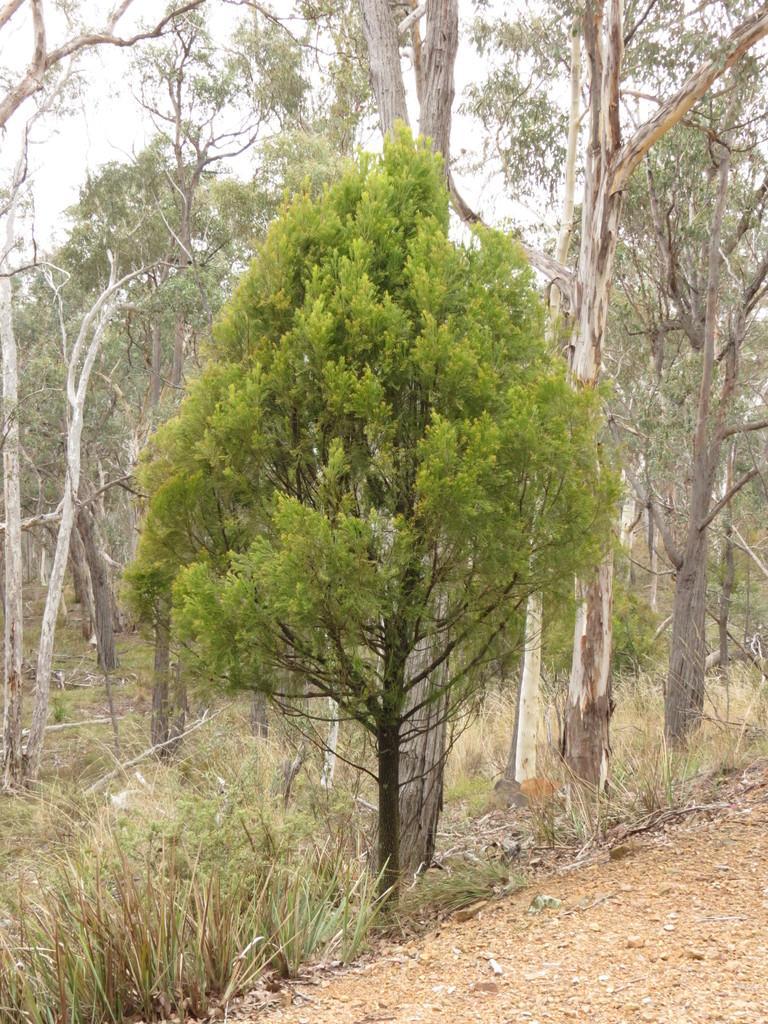Please provide a concise description of this image. In this image, we can see so many trees, plants, grass. At the bottom, there is a ground. Background we can see the sky. 